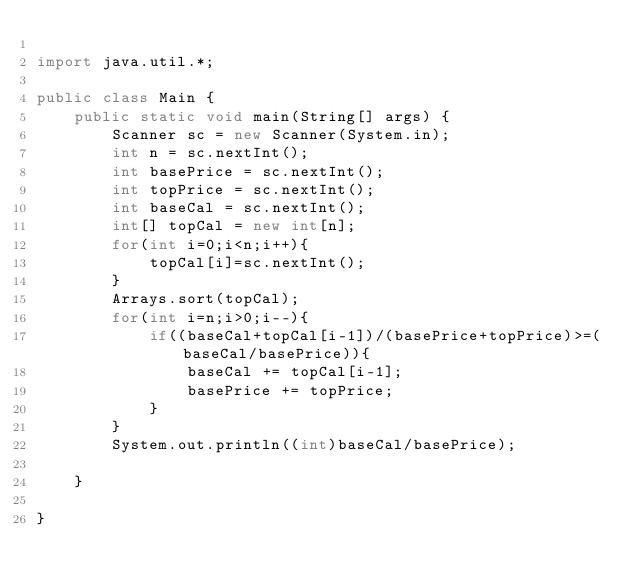<code> <loc_0><loc_0><loc_500><loc_500><_Java_>
import java.util.*;

public class Main {
	public static void main(String[] args) {
		Scanner sc = new Scanner(System.in);
		int n = sc.nextInt();
		int basePrice = sc.nextInt();
		int topPrice = sc.nextInt();
		int baseCal = sc.nextInt();
		int[] topCal = new int[n];
		for(int i=0;i<n;i++){
			topCal[i]=sc.nextInt();
		}
		Arrays.sort(topCal);
		for(int i=n;i>0;i--){
			if((baseCal+topCal[i-1])/(basePrice+topPrice)>=(baseCal/basePrice)){
				baseCal += topCal[i-1];
				basePrice += topPrice;
			}
		}
		System.out.println((int)baseCal/basePrice);

	}

}</code> 